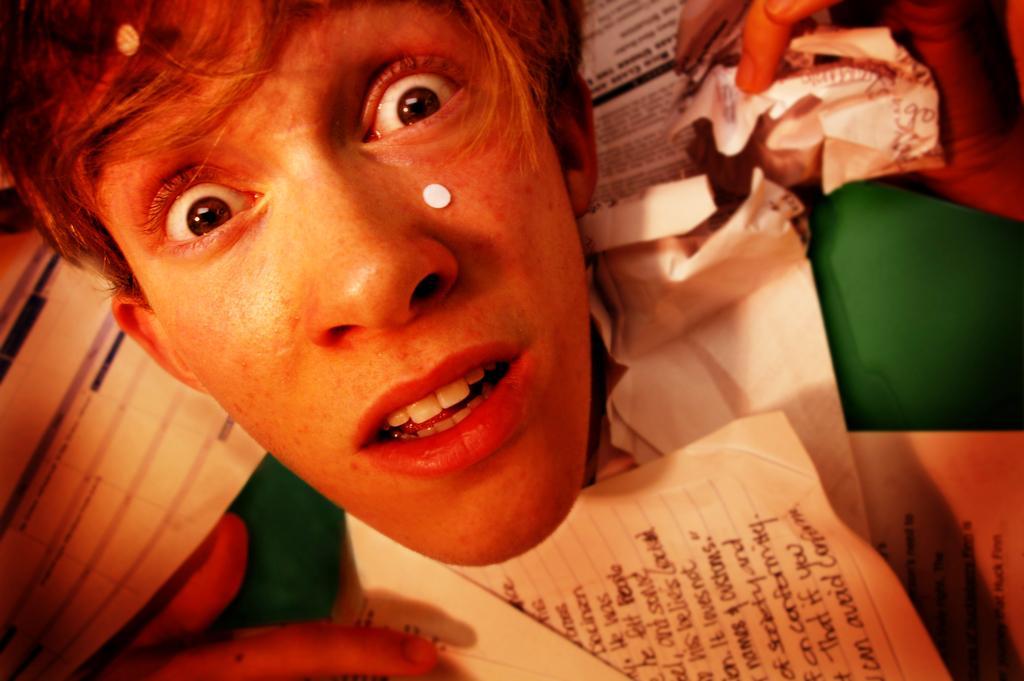Could you give a brief overview of what you see in this image? In this image, we can see a boy and there are some papers. 